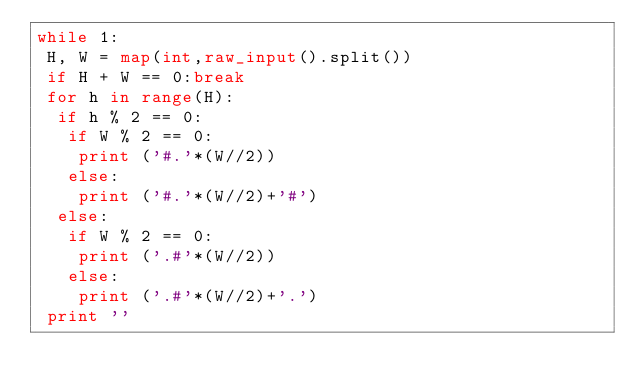<code> <loc_0><loc_0><loc_500><loc_500><_Python_>while 1:
 H, W = map(int,raw_input().split())
 if H + W == 0:break
 for h in range(H):
  if h % 2 == 0:
   if W % 2 == 0:
    print ('#.'*(W//2))
   else:
    print ('#.'*(W//2)+'#')
  else:
   if W % 2 == 0:
    print ('.#'*(W//2))
   else:
    print ('.#'*(W//2)+'.')
 print ''</code> 